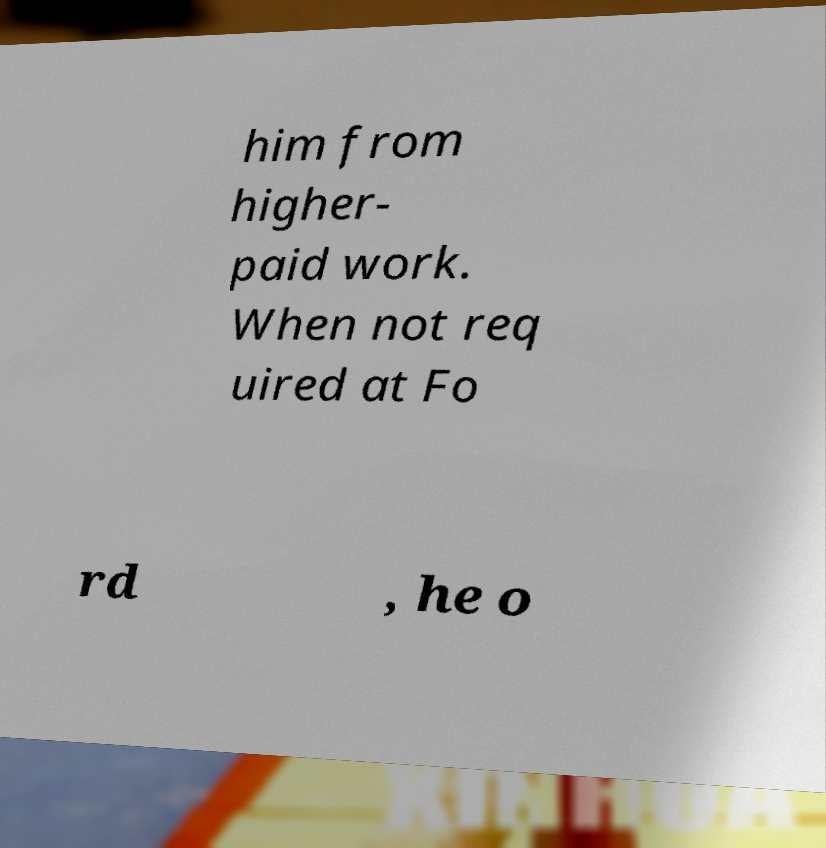What messages or text are displayed in this image? I need them in a readable, typed format. him from higher- paid work. When not req uired at Fo rd , he o 